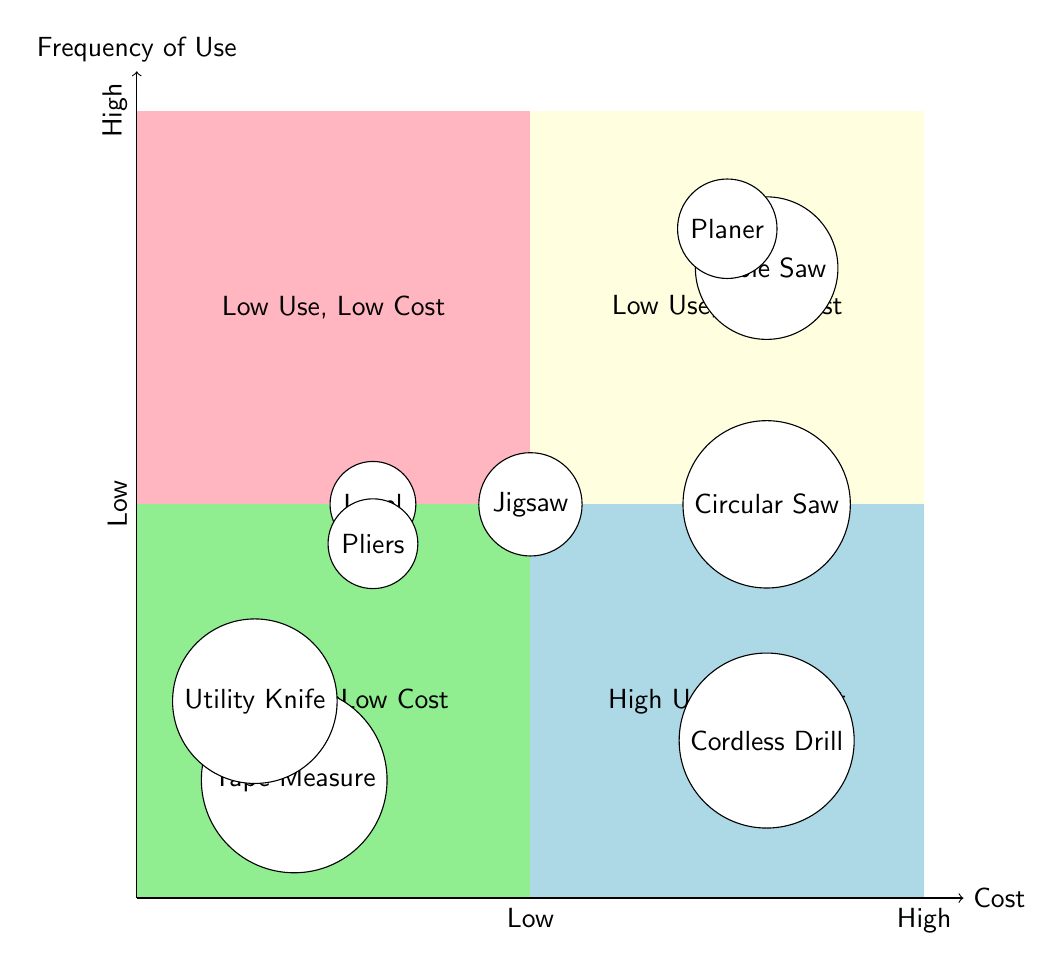What tool is in the High Use, Low Cost quadrant? The High Use, Low Cost quadrant contains tools that are frequently used and inexpensive. From the diagram, we can see that both the Hammer and the Tape Measure fall into this category.
Answer: Hammer, Tape Measure How many tools are in the Low Use, High Cost quadrant? The Low Use, High Cost quadrant contains tools that are used infrequently and are expensive. By examining the diagram, we see that there are two tools listed here: the Table Saw and the Planer.
Answer: 2 Which tool has High frequency of use but Low cost? We check the quadrants for tools that are categorized as having high usage and low cost. The Hammer, Tape Measure, and Utility Knife are clearly marked as such in the lower left quadrant.
Answer: Hammer, Tape Measure, Utility Knife Is there any tool that has Medium frequency of use and Low cost? To find this, we look in the quadrant corresponding to Medium frequency of use and Low cost. Placing focus on the quadrant and checking the data, we confirm that Pliers is the tool that meets the criteria.
Answer: Pliers What is the cost of the Circular Saw? The Circular Saw is positioned in the High Cost area of the quadrant. By looking directly at its label in the diagram, we can categorize it as a High cost tool, based on its placement in the top right quadrant.
Answer: High How does the frequency of use for Jigsaw compare to that of Hammer? The Jigsaw is in the Medium frequency quadrant while the Hammer is categorized as High frequency use. Hence, the Hammer is used more frequently than the Jigsaw.
Answer: Hammer is used more frequently What is the most expensive tool that is used frequently? We identify the tools that fall into the High Use and High Cost quadrant, which are marked as being both frequently used and expensive. From the diagram, it is evident that the only tool here is the Cordless Drill.
Answer: Cordless Drill Which tool has the lowest frequency of use? To determine the lowest frequency of use, we reference the quadrant labeled Low Use. Both the Table Saw and Planer are present here, indicating they have the least usage among the listed tools.
Answer: Table Saw, Planer 